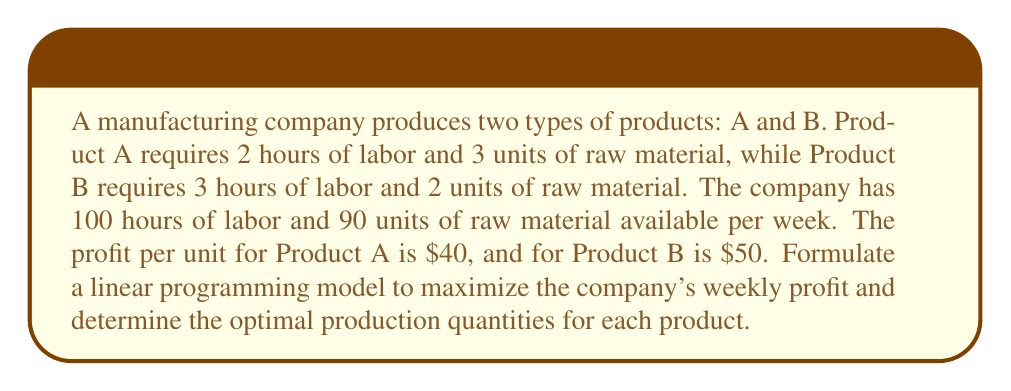Solve this math problem. To solve this problem, we'll use linear programming. Let's define our variables and constraints:

Let $x$ be the number of units of Product A produced
Let $y$ be the number of units of Product B produced

Objective function (maximize profit):
$$\text{Max } Z = 40x + 50y$$

Constraints:
1. Labor constraint: $2x + 3y \leq 100$
2. Raw material constraint: $3x + 2y \leq 90$
3. Non-negativity: $x \geq 0, y \geq 0$

To solve this, we'll use the graphical method:

1. Plot the constraints:
   - Labor: $2x + 3y = 100$ intersects at (50, 0) and (0, 33.33)
   - Raw material: $3x + 2y = 90$ intersects at (30, 0) and (0, 45)

2. Identify the feasible region (the area that satisfies all constraints).

3. Find the corner points of the feasible region:
   - (0, 0)
   - (30, 0)
   - (0, 33.33)
   - Intersection of $2x + 3y = 100$ and $3x + 2y = 90$

To find the intersection, solve:
$$2x + 3y = 100$$
$$3x + 2y = 90$$

Multiplying the first equation by 3 and the second by -2:
$$6x + 9y = 300$$
$$-6x - 4y = -180$$

Adding these equations:
$$5y = 120$$
$$y = 24$$

Substituting back:
$$2x + 3(24) = 100$$
$$2x = 28$$
$$x = 14$$

So, the intersection point is (14, 24).

4. Evaluate the objective function at each corner point:
   - (0, 0): $Z = 0$
   - (30, 0): $Z = 1200$
   - (0, 33.33): $Z = 1666.5$
   - (14, 24): $Z = 1760$

The maximum profit occurs at (14, 24), so the optimal solution is to produce 14 units of Product A and 24 units of Product B.
Answer: The optimal production quantities are 14 units of Product A and 24 units of Product B, yielding a maximum weekly profit of $1760. 